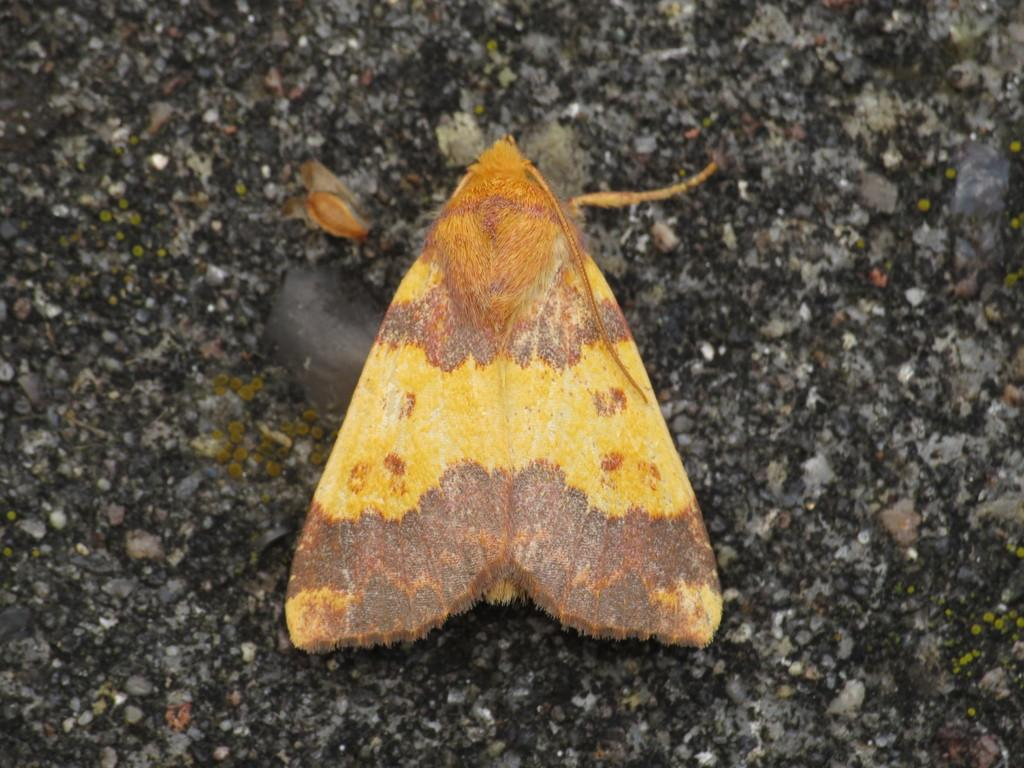What is present in the image? There is a fly in the image. Where is the fly located in the image? The fly is on the ground in the image. What part of the image does the fly occupy? The fly is in the foreground of the image. What thought is the fly having in the image? Flies do not have thoughts, so it is not possible to determine what the fly might be thinking in the image. 